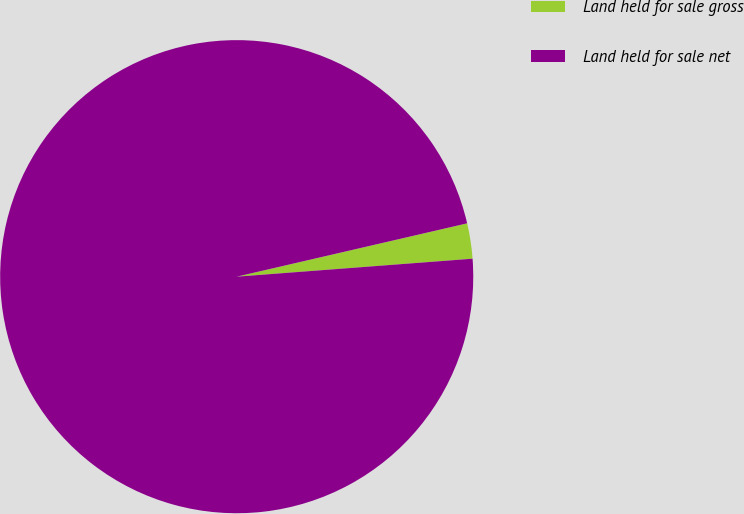Convert chart to OTSL. <chart><loc_0><loc_0><loc_500><loc_500><pie_chart><fcel>Land held for sale gross<fcel>Land held for sale net<nl><fcel>2.41%<fcel>97.59%<nl></chart> 